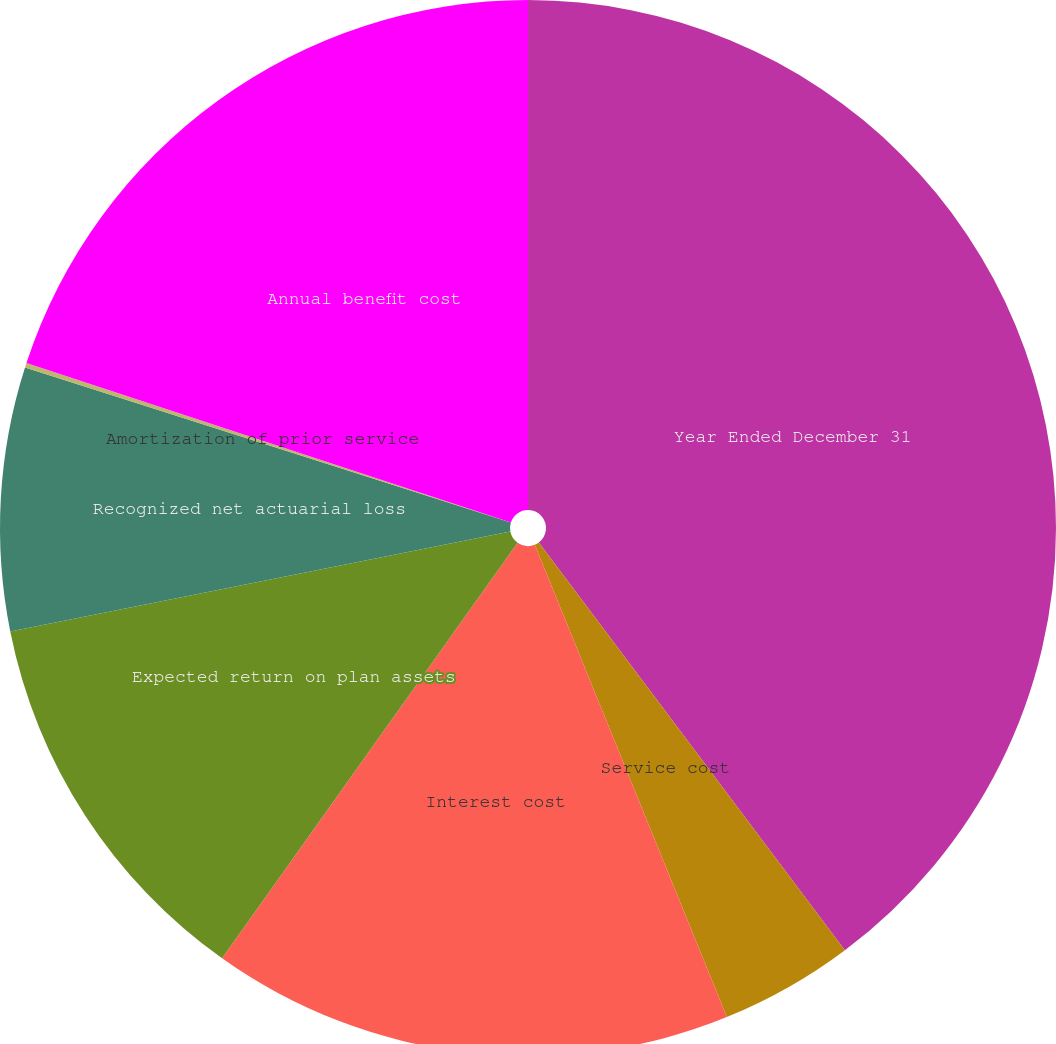Convert chart to OTSL. <chart><loc_0><loc_0><loc_500><loc_500><pie_chart><fcel>Year Ended December 31<fcel>Service cost<fcel>Interest cost<fcel>Expected return on plan assets<fcel>Recognized net actuarial loss<fcel>Amortization of prior service<fcel>Annual benefit cost<nl><fcel>39.75%<fcel>4.1%<fcel>15.98%<fcel>12.02%<fcel>8.06%<fcel>0.14%<fcel>19.94%<nl></chart> 